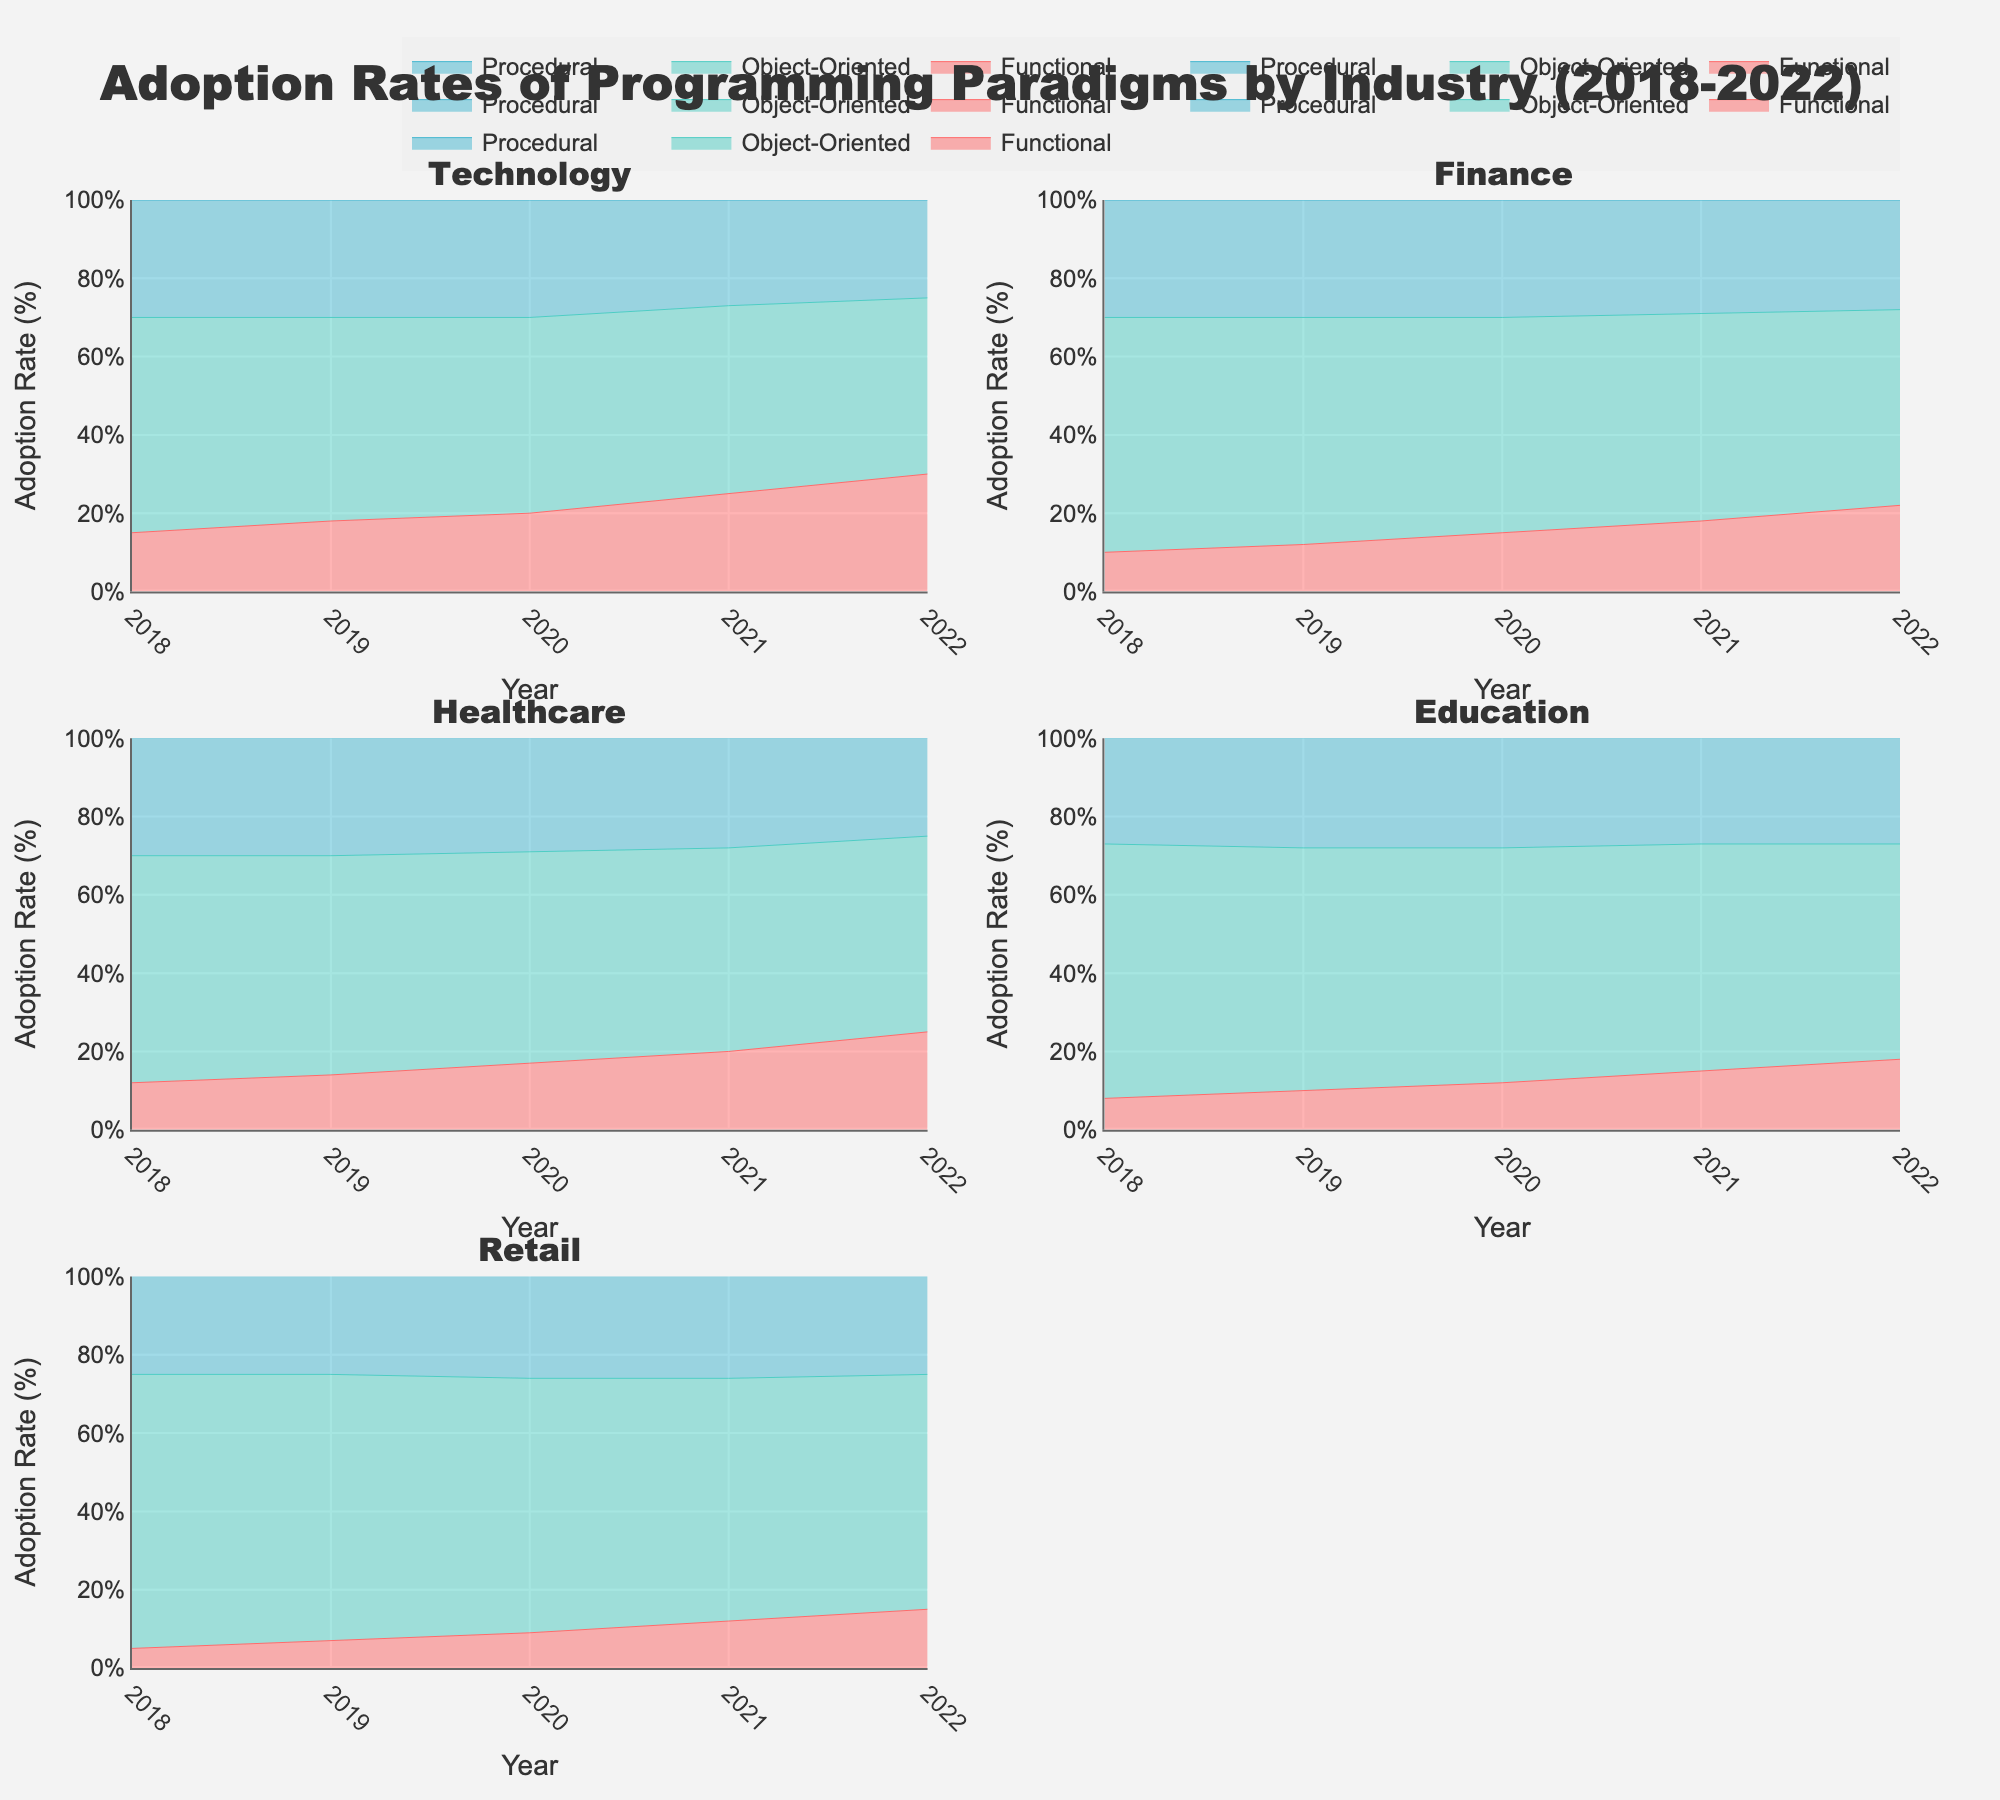How many industry sectors are compared in the figure? The figure represents industries through subplot titles. There are six subplot titles which correspond to six industry sectors.
Answer: 6 What is the adoption rate trend for Functional programming in the Technology sector over the five years? Observing the area for the Functional programming paradigm in the Technology sector subplot, the adoption rate starts at 15% in 2018 and gradually increases to 30% in 2022.
Answer: Increasing Between Procedural and Object-Oriented programming, which one has a higher adoption rate in the Healthcare sector in 2022? In the Healthcare subplot for 2022, examining the stack areas, the segment for Object-Oriented programming is larger than Procedural programming, indicating a higher adoption rate.
Answer: Object-Oriented What is the trend difference in adoption rates for Functional programming between the Education and Retail sectors from 2018 to 2022? Monitoring the subplots for both Education and Retail sectors, the Functional programming adoption rate for Education starts at 8% and reaches 18% in 2022. In Retail, it begins at 5% and reaches 15% in 2022. Thus, both are increasing, but Education sees a 10% increase while Retail sees a 10% rise.
Answer: Both increasing; Education has 10% rise, Retail has 10% rise Which programming paradigm shows the least variation in adoption rates across all sectors from 2018 to 2022? By inspecting the size and consistency of areas for each paradigm across all subplots, Procedural programming maintains the most stable adoption rates, staying around 25-30% with minor fluctuations.
Answer: Procedural What is the highest adoption rate observed for Functional programming in any industry sector and year? Reviewing all subplots for the height of the Functional programming area's maximum point, Technology sector in 2022 shows an adoption rate of 30%.
Answer: 30% Which sector and year combination shows the lowest adoption rate for Procedural programming? Examining each subplot, Retail sector in 2022 shows the smallest area for Procedural programming, indicating around 25%.
Answer: Retail, 2022 How does the adoption rate of Object-Oriented programming in the Finance sector change from 2018 to 2022? Analyzing the Finance subplot, the rate starts at 60% in 2018 and decreases progressively to 50% in 2022.
Answer: Decreasing Between 2019 and 2020, which industry sector has the greatest increase in adoption rates for Functional programming? Observing subplot changes for Functional programming between 2019 and 2020, the Technology sector increases from 18% to 20%, which is 2%, larger than in other sectors.
Answer: Technology In which sector does Functional programming surpass 20% adoption rate first and in what year? Review the subplots to identify the year when Functional programming first surpasses the 20% mark, visible in Technology sector in 2020.
Answer: Technology, 2020 